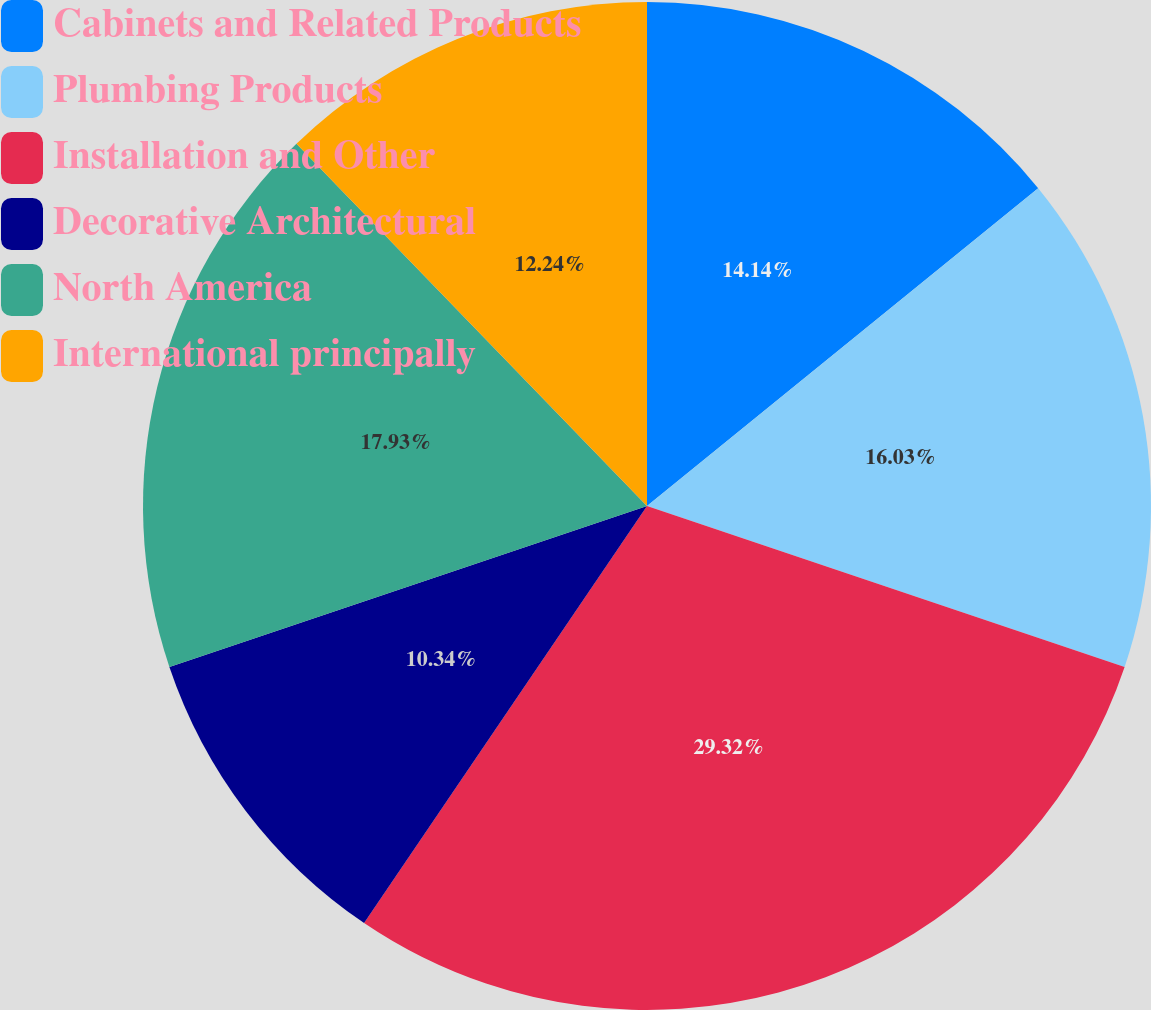Convert chart. <chart><loc_0><loc_0><loc_500><loc_500><pie_chart><fcel>Cabinets and Related Products<fcel>Plumbing Products<fcel>Installation and Other<fcel>Decorative Architectural<fcel>North America<fcel>International principally<nl><fcel>14.14%<fcel>16.03%<fcel>29.31%<fcel>10.34%<fcel>17.93%<fcel>12.24%<nl></chart> 